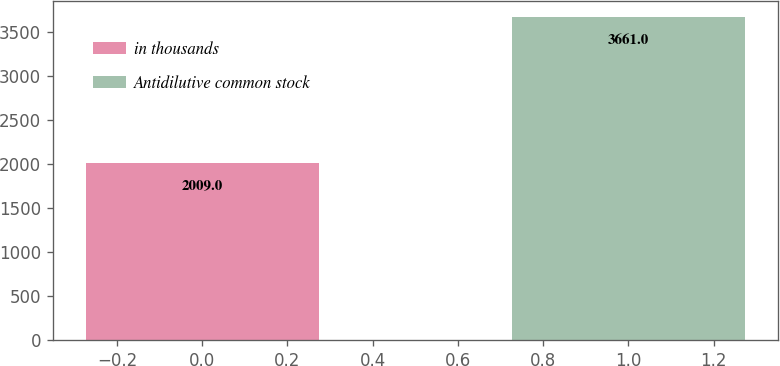Convert chart to OTSL. <chart><loc_0><loc_0><loc_500><loc_500><bar_chart><fcel>in thousands<fcel>Antidilutive common stock<nl><fcel>2009<fcel>3661<nl></chart> 